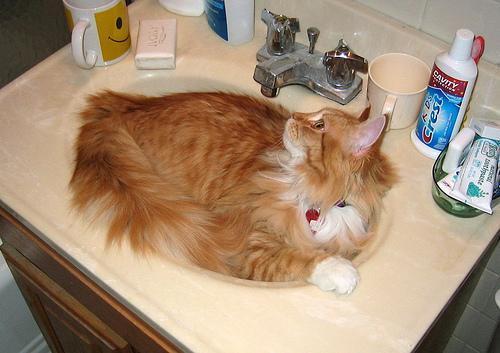How many cats?
Give a very brief answer. 1. How many sinks are there?
Give a very brief answer. 2. How many cups are there?
Give a very brief answer. 2. How many pickles are on the hot dog in the foiled wrapper?
Give a very brief answer. 0. 